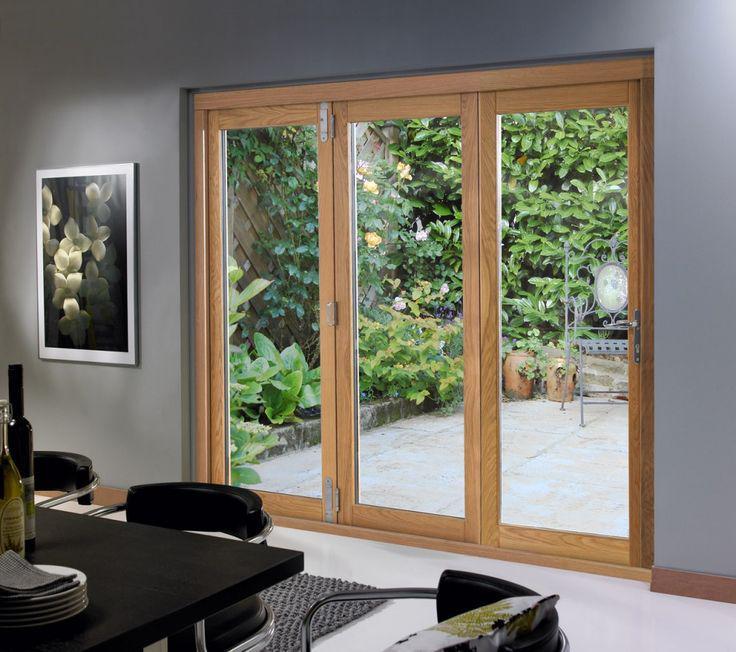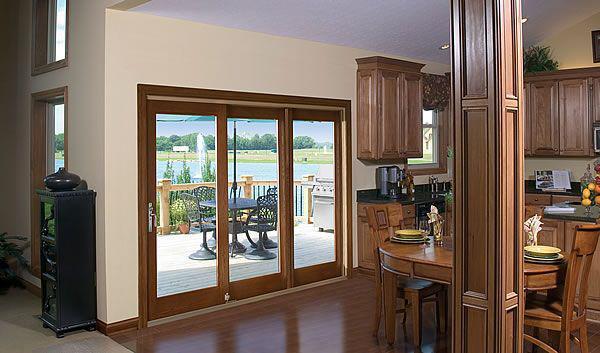The first image is the image on the left, the second image is the image on the right. For the images displayed, is the sentence "The doors in the right image are open." factually correct? Answer yes or no. No. 